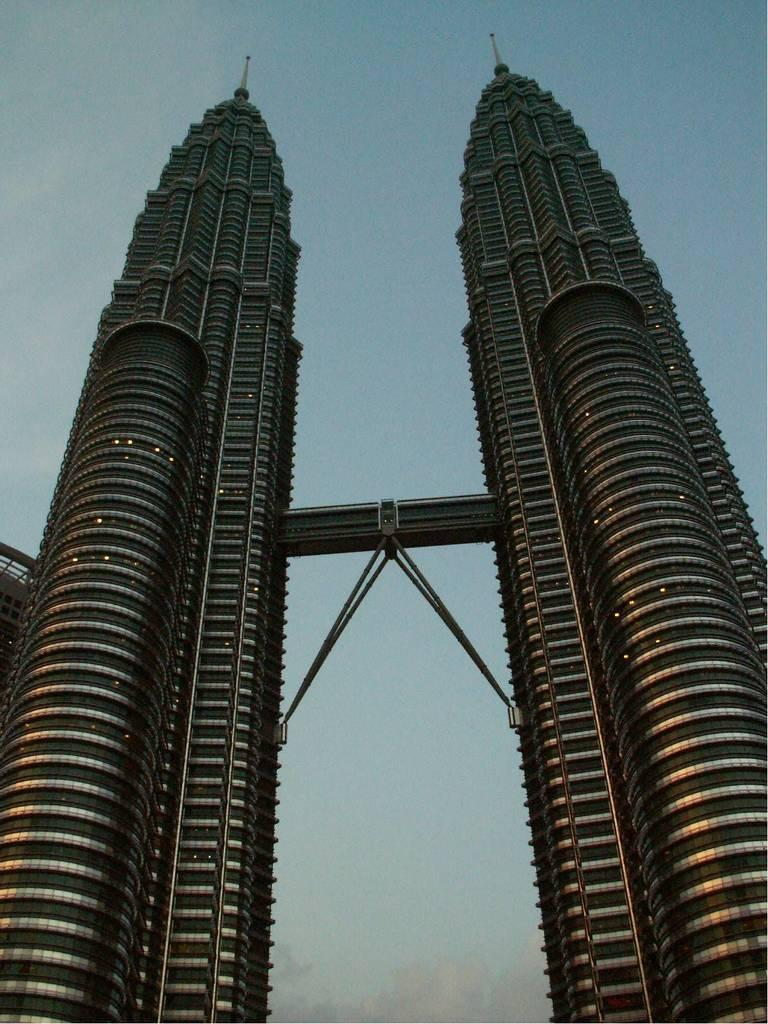What type of structures are located in the middle of the image? There are two tower buildings in the middle of the image. Can you describe the background of the image? The sky is visible in the background of the image. Are there any cobwebs visible on the tower buildings in the image? There is no mention of cobwebs in the provided facts, and therefore it cannot be determined if any are present. 